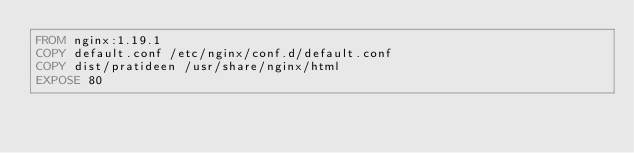<code> <loc_0><loc_0><loc_500><loc_500><_Dockerfile_>FROM nginx:1.19.1
COPY default.conf /etc/nginx/conf.d/default.conf
COPY dist/pratideen /usr/share/nginx/html
EXPOSE 80
</code> 